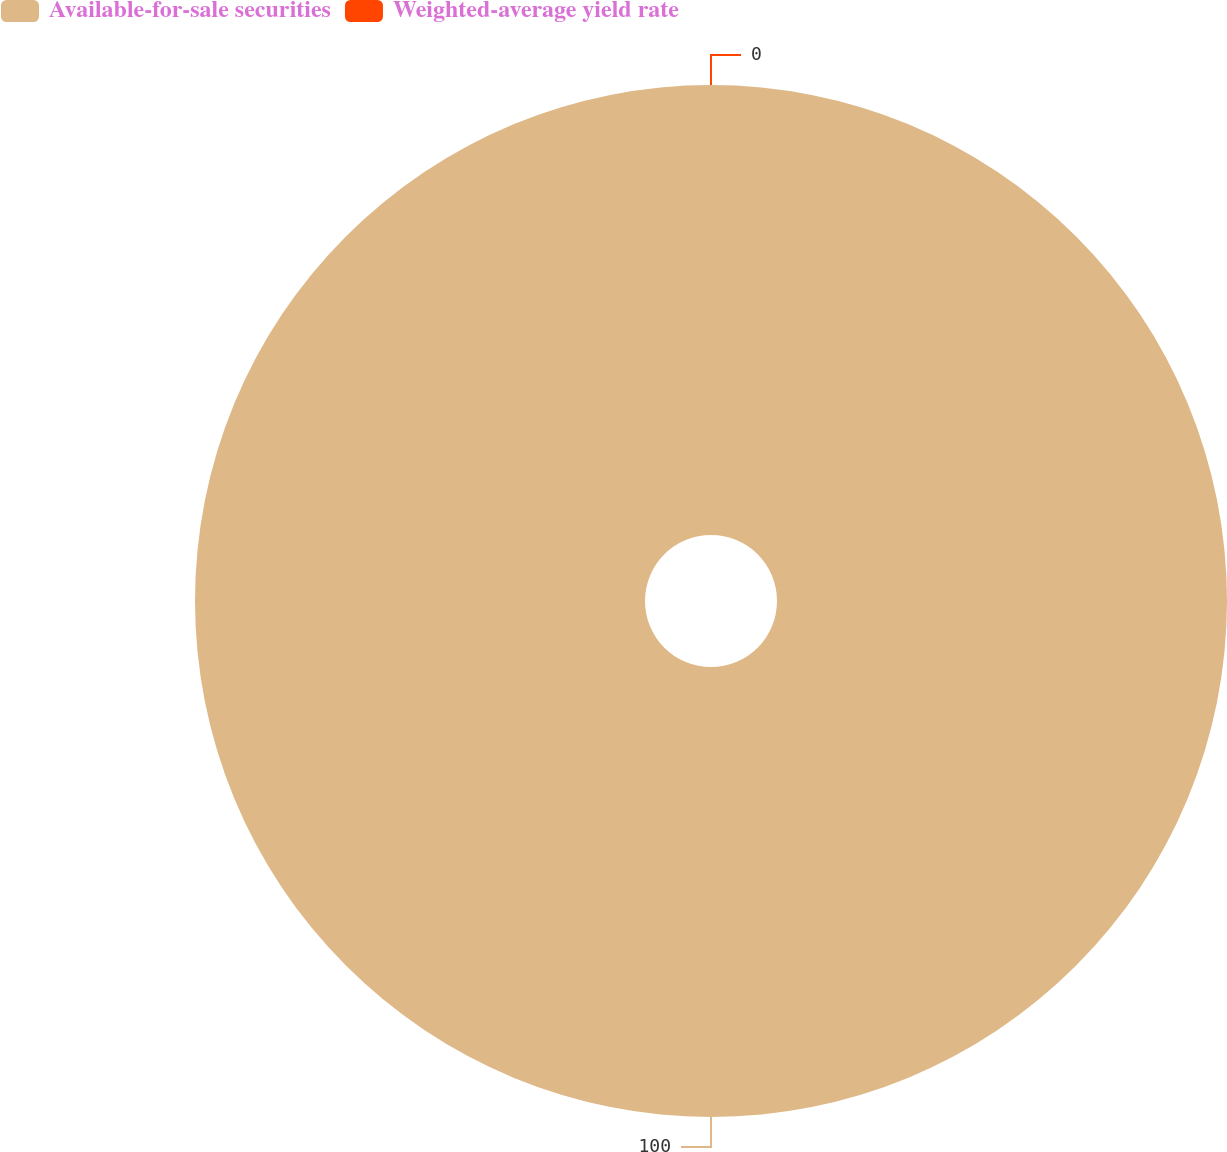Convert chart. <chart><loc_0><loc_0><loc_500><loc_500><pie_chart><fcel>Available-for-sale securities<fcel>Weighted-average yield rate<nl><fcel>100.0%<fcel>0.0%<nl></chart> 